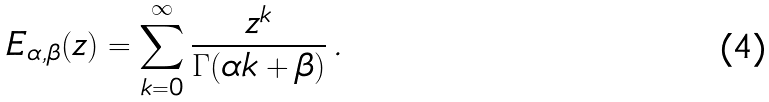<formula> <loc_0><loc_0><loc_500><loc_500>E _ { \alpha , \beta } ( z ) = \sum _ { k = 0 } ^ { \infty } \frac { z ^ { k } } { \Gamma ( \alpha k + \beta ) } \, .</formula> 